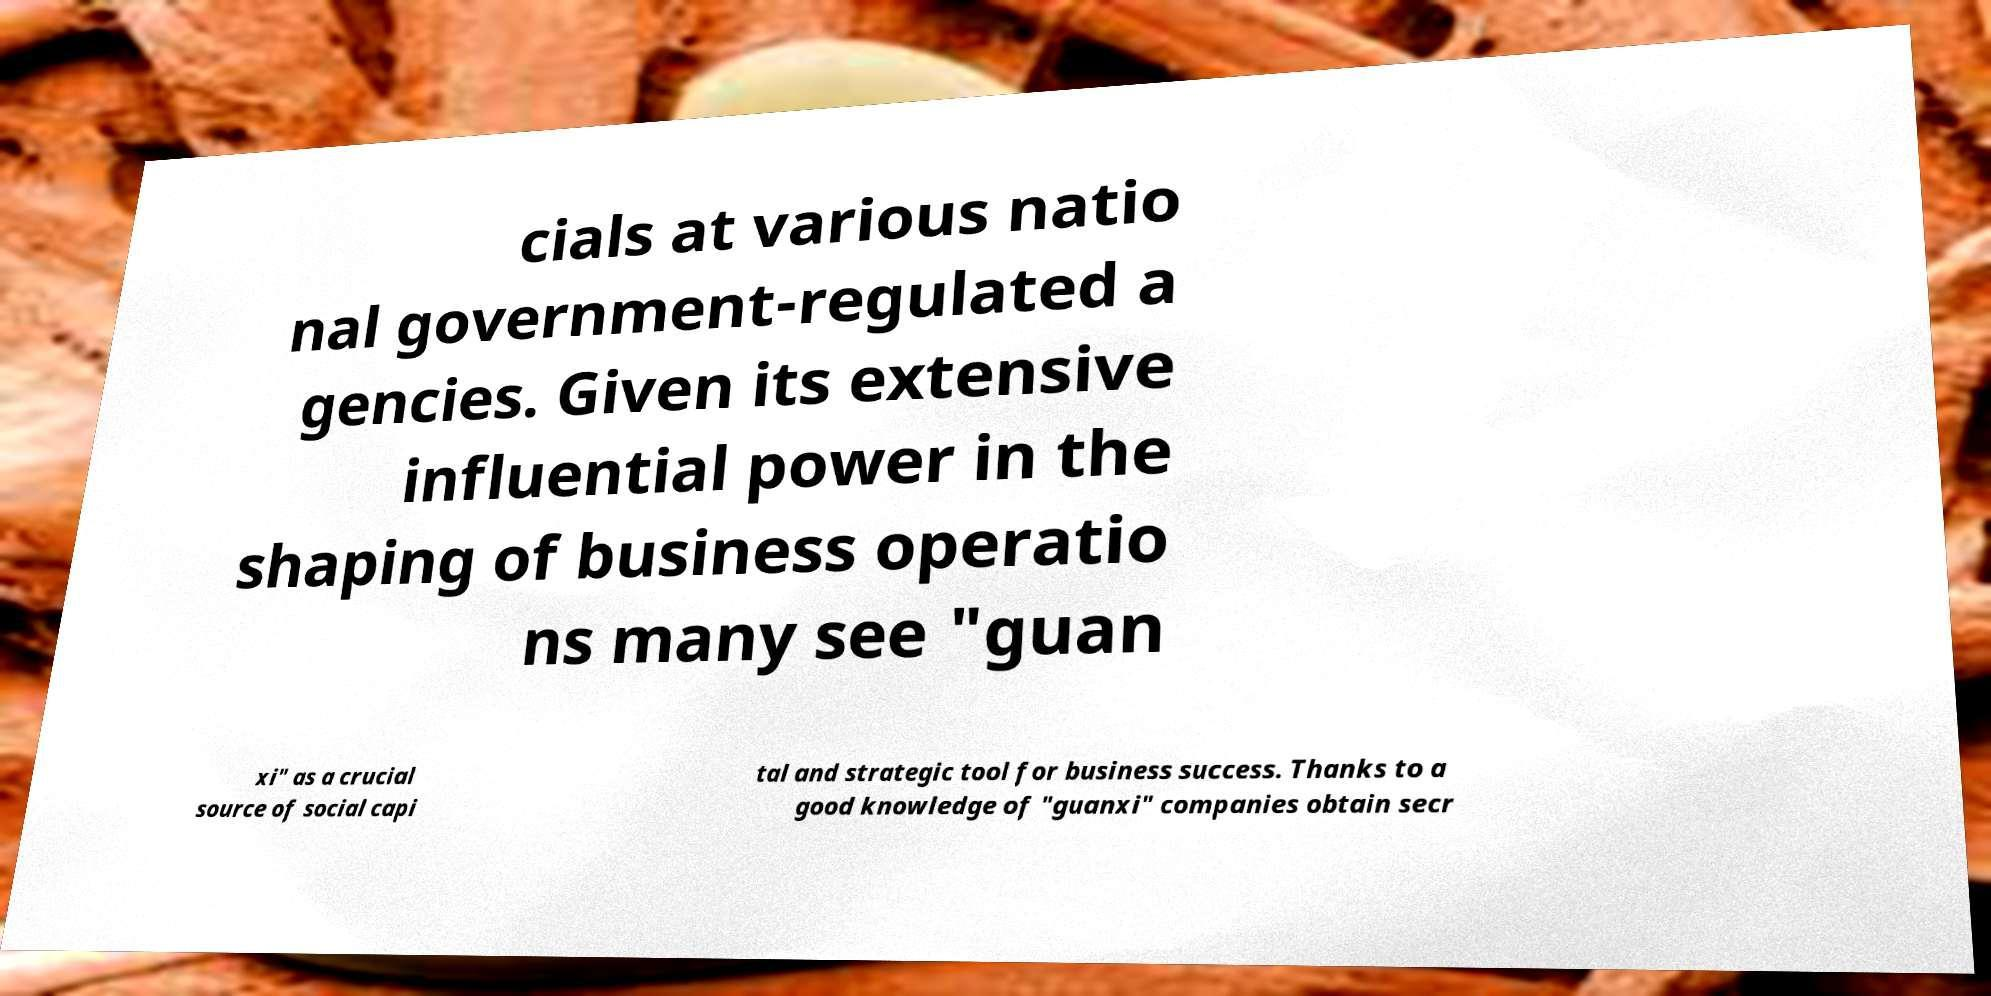Could you assist in decoding the text presented in this image and type it out clearly? cials at various natio nal government-regulated a gencies. Given its extensive influential power in the shaping of business operatio ns many see "guan xi" as a crucial source of social capi tal and strategic tool for business success. Thanks to a good knowledge of "guanxi" companies obtain secr 